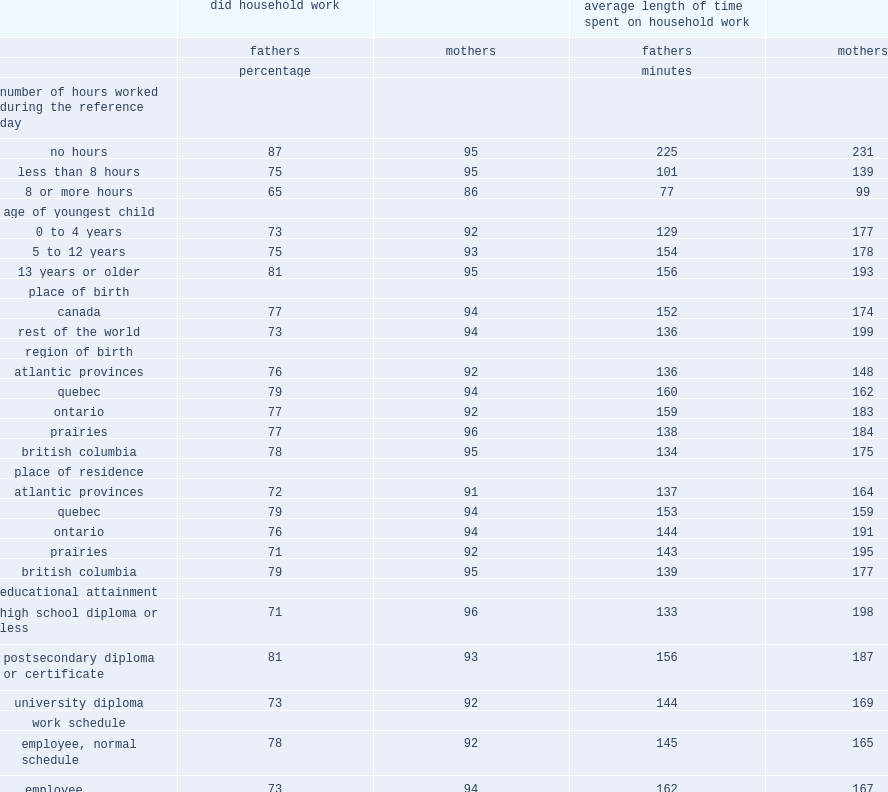What's the percentage of fathers who had worked 8 hours or more in household work. 65.0. How many minutes did fathers who had not participated in paid work but who had performed household work during the reference day, the average time spenting on household. 225.0. How many minutes did fathers who had participated in paid work 8 hours or more, the average time spenting on household. 77.0. 